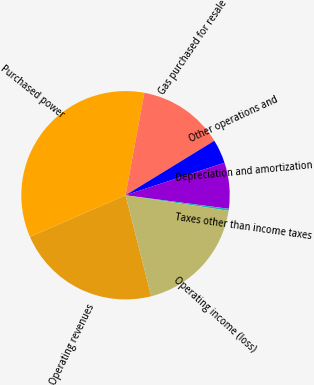Convert chart. <chart><loc_0><loc_0><loc_500><loc_500><pie_chart><fcel>Operating revenues<fcel>Purchased power<fcel>Gas purchased for resale<fcel>Other operations and<fcel>Depreciation and amortization<fcel>Taxes other than income taxes<fcel>Operating income (loss)<nl><fcel>22.44%<fcel>34.42%<fcel>13.34%<fcel>3.71%<fcel>7.13%<fcel>0.3%<fcel>18.65%<nl></chart> 